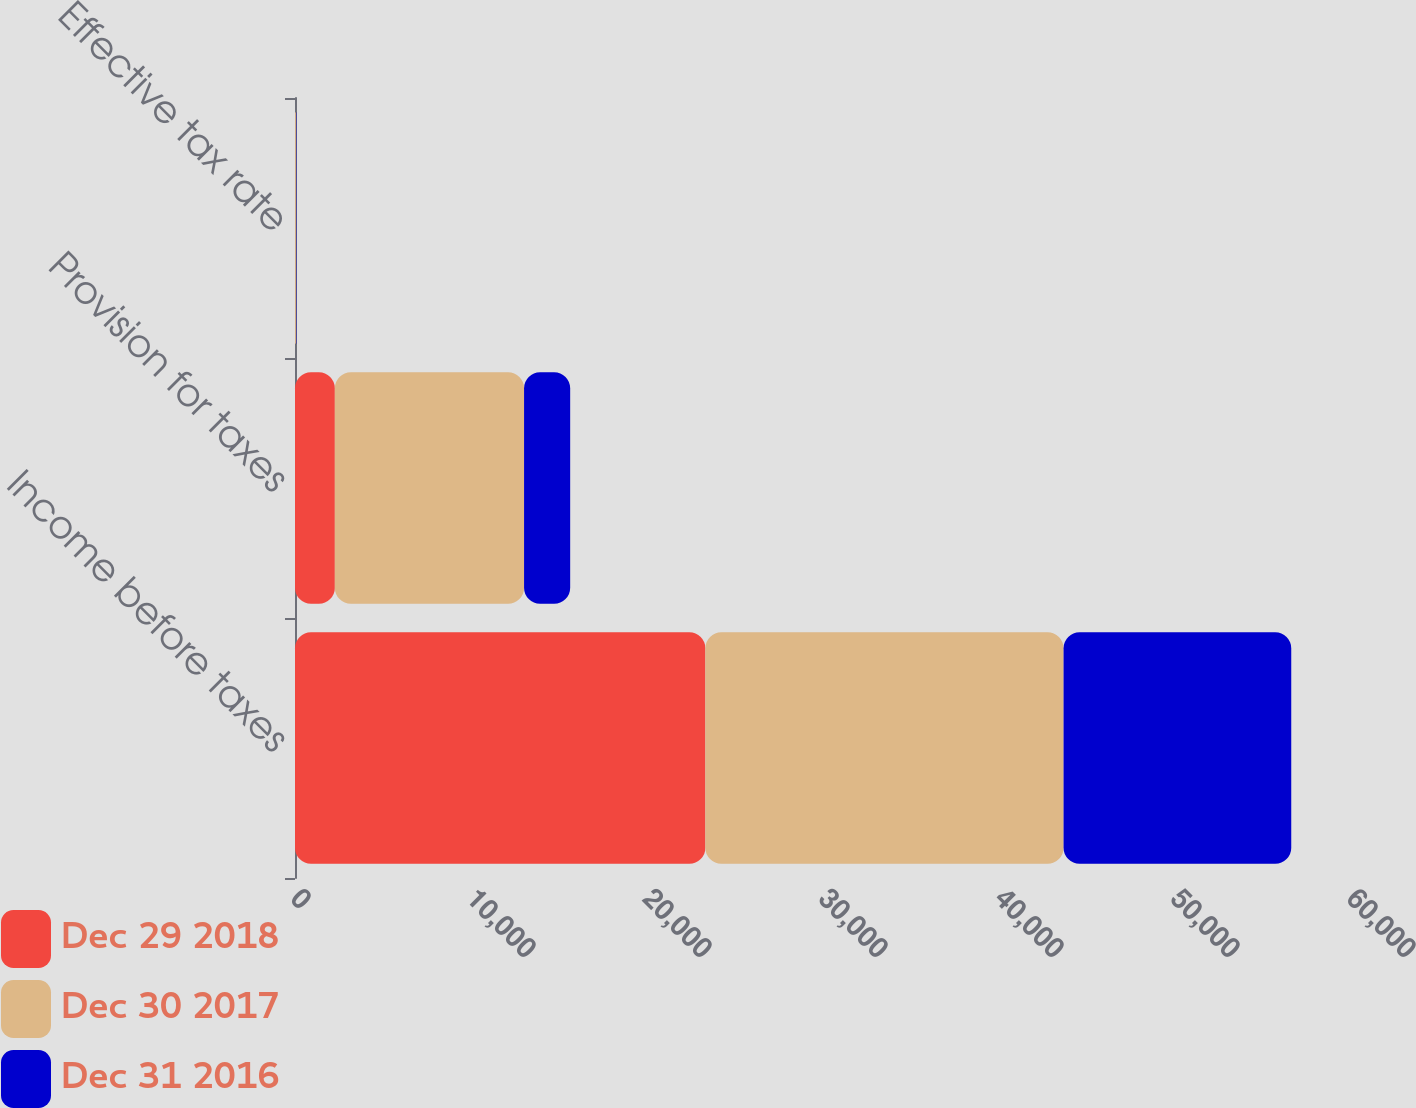Convert chart. <chart><loc_0><loc_0><loc_500><loc_500><stacked_bar_chart><ecel><fcel>Income before taxes<fcel>Provision for taxes<fcel>Effective tax rate<nl><fcel>Dec 29 2018<fcel>23317<fcel>2264<fcel>9.7<nl><fcel>Dec 30 2017<fcel>20352<fcel>10751<fcel>52.8<nl><fcel>Dec 31 2016<fcel>12936<fcel>2620<fcel>20.3<nl></chart> 